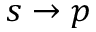Convert formula to latex. <formula><loc_0><loc_0><loc_500><loc_500>s \rightarrow p</formula> 